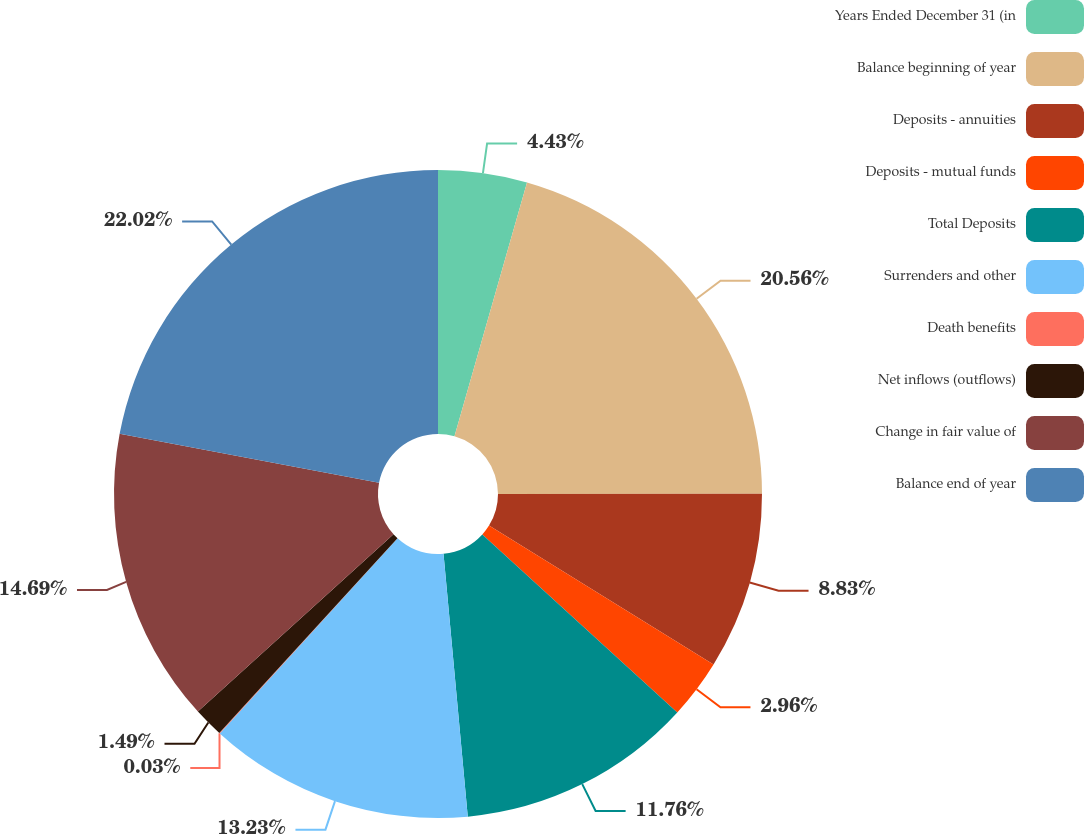Convert chart to OTSL. <chart><loc_0><loc_0><loc_500><loc_500><pie_chart><fcel>Years Ended December 31 (in<fcel>Balance beginning of year<fcel>Deposits - annuities<fcel>Deposits - mutual funds<fcel>Total Deposits<fcel>Surrenders and other<fcel>Death benefits<fcel>Net inflows (outflows)<fcel>Change in fair value of<fcel>Balance end of year<nl><fcel>4.43%<fcel>20.56%<fcel>8.83%<fcel>2.96%<fcel>11.76%<fcel>13.23%<fcel>0.03%<fcel>1.49%<fcel>14.69%<fcel>22.03%<nl></chart> 